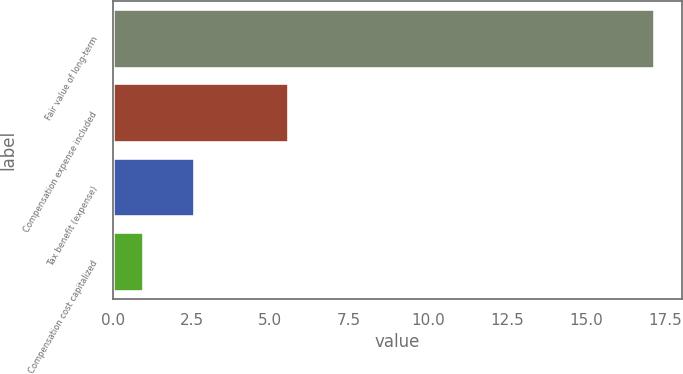<chart> <loc_0><loc_0><loc_500><loc_500><bar_chart><fcel>Fair value of long-term<fcel>Compensation expense included<fcel>Tax benefit (expense)<fcel>Compensation cost capitalized<nl><fcel>17.2<fcel>5.6<fcel>2.62<fcel>1<nl></chart> 